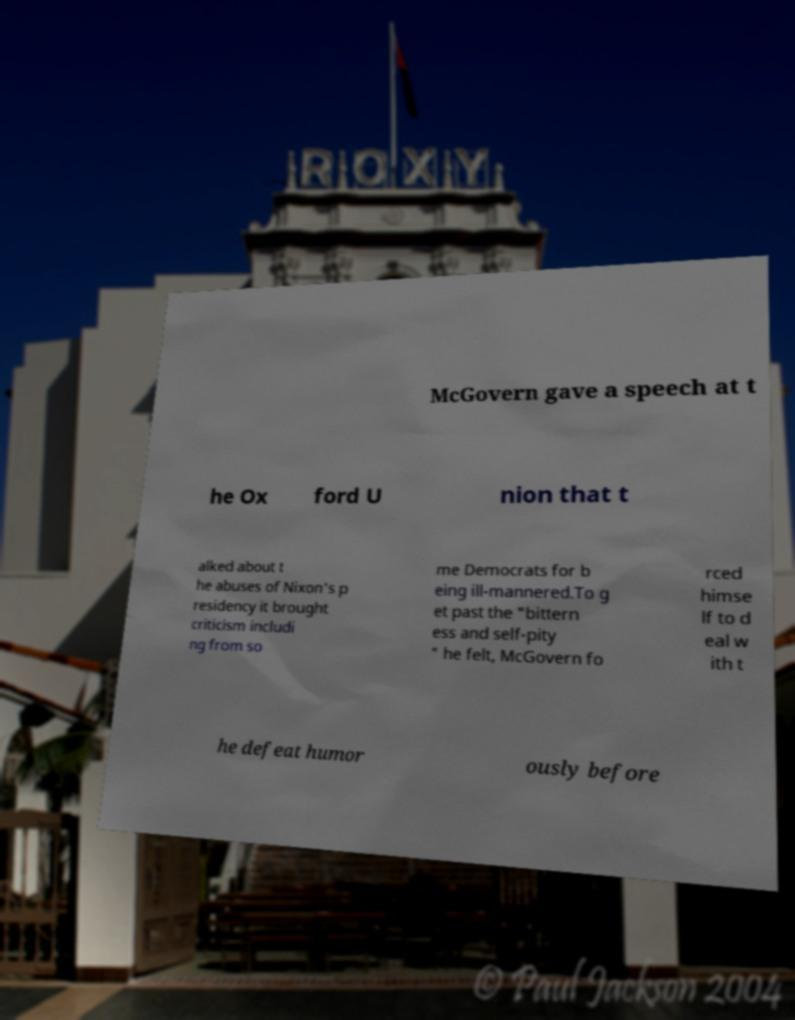Can you accurately transcribe the text from the provided image for me? McGovern gave a speech at t he Ox ford U nion that t alked about t he abuses of Nixon's p residency it brought criticism includi ng from so me Democrats for b eing ill-mannered.To g et past the "bittern ess and self-pity " he felt, McGovern fo rced himse lf to d eal w ith t he defeat humor ously before 